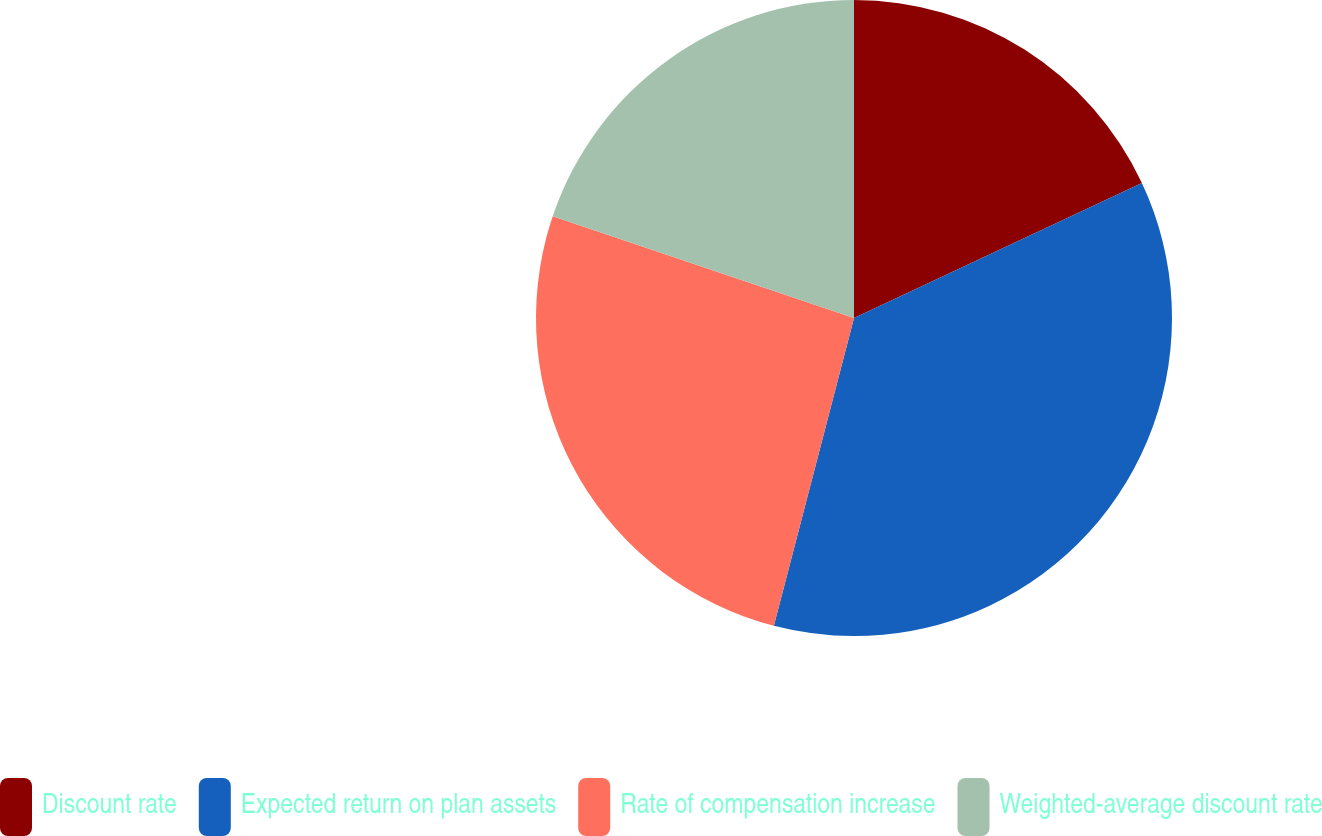<chart> <loc_0><loc_0><loc_500><loc_500><pie_chart><fcel>Discount rate<fcel>Expected return on plan assets<fcel>Rate of compensation increase<fcel>Weighted-average discount rate<nl><fcel>18.02%<fcel>36.04%<fcel>26.13%<fcel>19.82%<nl></chart> 